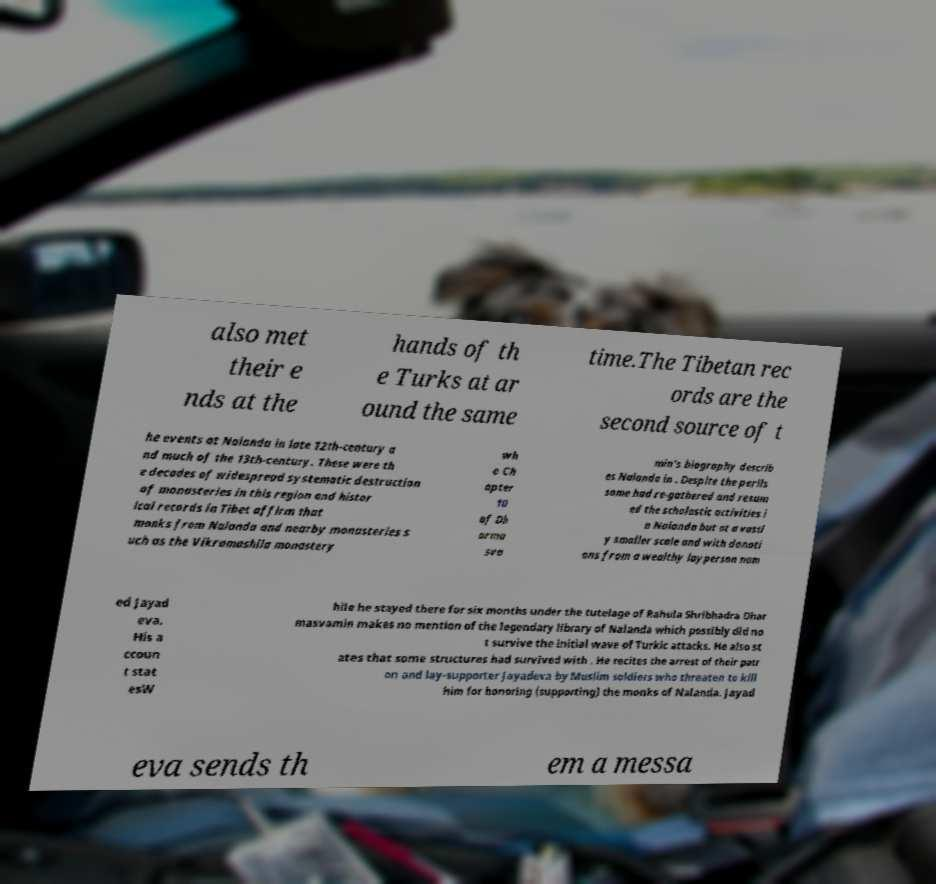Please read and relay the text visible in this image. What does it say? also met their e nds at the hands of th e Turks at ar ound the same time.The Tibetan rec ords are the second source of t he events at Nalanda in late 12th-century a nd much of the 13th-century. These were th e decades of widespread systematic destruction of monasteries in this region and histor ical records in Tibet affirm that monks from Nalanda and nearby monasteries s uch as the Vikramashila monastery wh o Ch apter 10 of Dh arma sva min's biography describ es Nalanda in . Despite the perils some had re-gathered and resum ed the scholastic activities i n Nalanda but at a vastl y smaller scale and with donati ons from a wealthy layperson nam ed Jayad eva. His a ccoun t stat esW hile he stayed there for six months under the tutelage of Rahula Shribhadra Dhar masvamin makes no mention of the legendary library of Nalanda which possibly did no t survive the initial wave of Turkic attacks. He also st ates that some structures had survived with . He recites the arrest of their patr on and lay-supporter Jayadeva by Muslim soldiers who threaten to kill him for honoring (supporting) the monks of Nalanda. Jayad eva sends th em a messa 